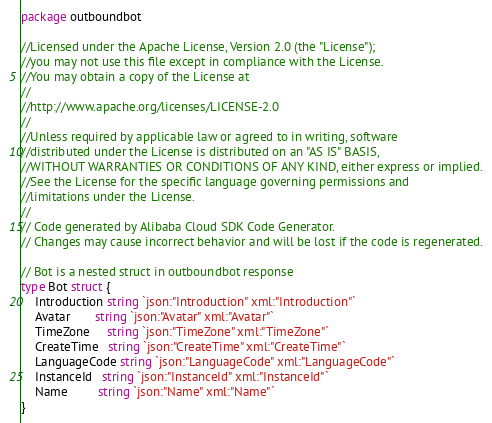<code> <loc_0><loc_0><loc_500><loc_500><_Go_>package outboundbot

//Licensed under the Apache License, Version 2.0 (the "License");
//you may not use this file except in compliance with the License.
//You may obtain a copy of the License at
//
//http://www.apache.org/licenses/LICENSE-2.0
//
//Unless required by applicable law or agreed to in writing, software
//distributed under the License is distributed on an "AS IS" BASIS,
//WITHOUT WARRANTIES OR CONDITIONS OF ANY KIND, either express or implied.
//See the License for the specific language governing permissions and
//limitations under the License.
//
// Code generated by Alibaba Cloud SDK Code Generator.
// Changes may cause incorrect behavior and will be lost if the code is regenerated.

// Bot is a nested struct in outboundbot response
type Bot struct {
	Introduction string `json:"Introduction" xml:"Introduction"`
	Avatar       string `json:"Avatar" xml:"Avatar"`
	TimeZone     string `json:"TimeZone" xml:"TimeZone"`
	CreateTime   string `json:"CreateTime" xml:"CreateTime"`
	LanguageCode string `json:"LanguageCode" xml:"LanguageCode"`
	InstanceId   string `json:"InstanceId" xml:"InstanceId"`
	Name         string `json:"Name" xml:"Name"`
}
</code> 